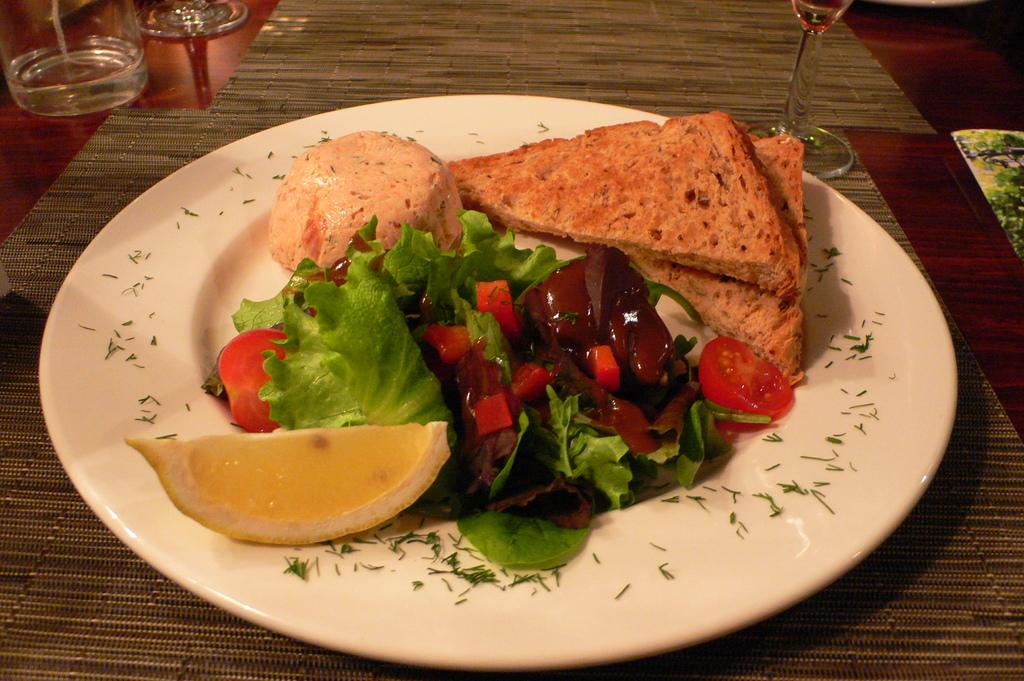What is the main object in the center of the image? There is a table in the center of the image. What is placed on the table? There is a plate containing food and glasses on the table. What is used to protect the table surface? There are mats on the table. What type of error can be seen on the plate in the image? There is no error present on the plate in the image; it contains food. What kind of bread is visible on the table in the image? There is no bread visible on the table in the image. 